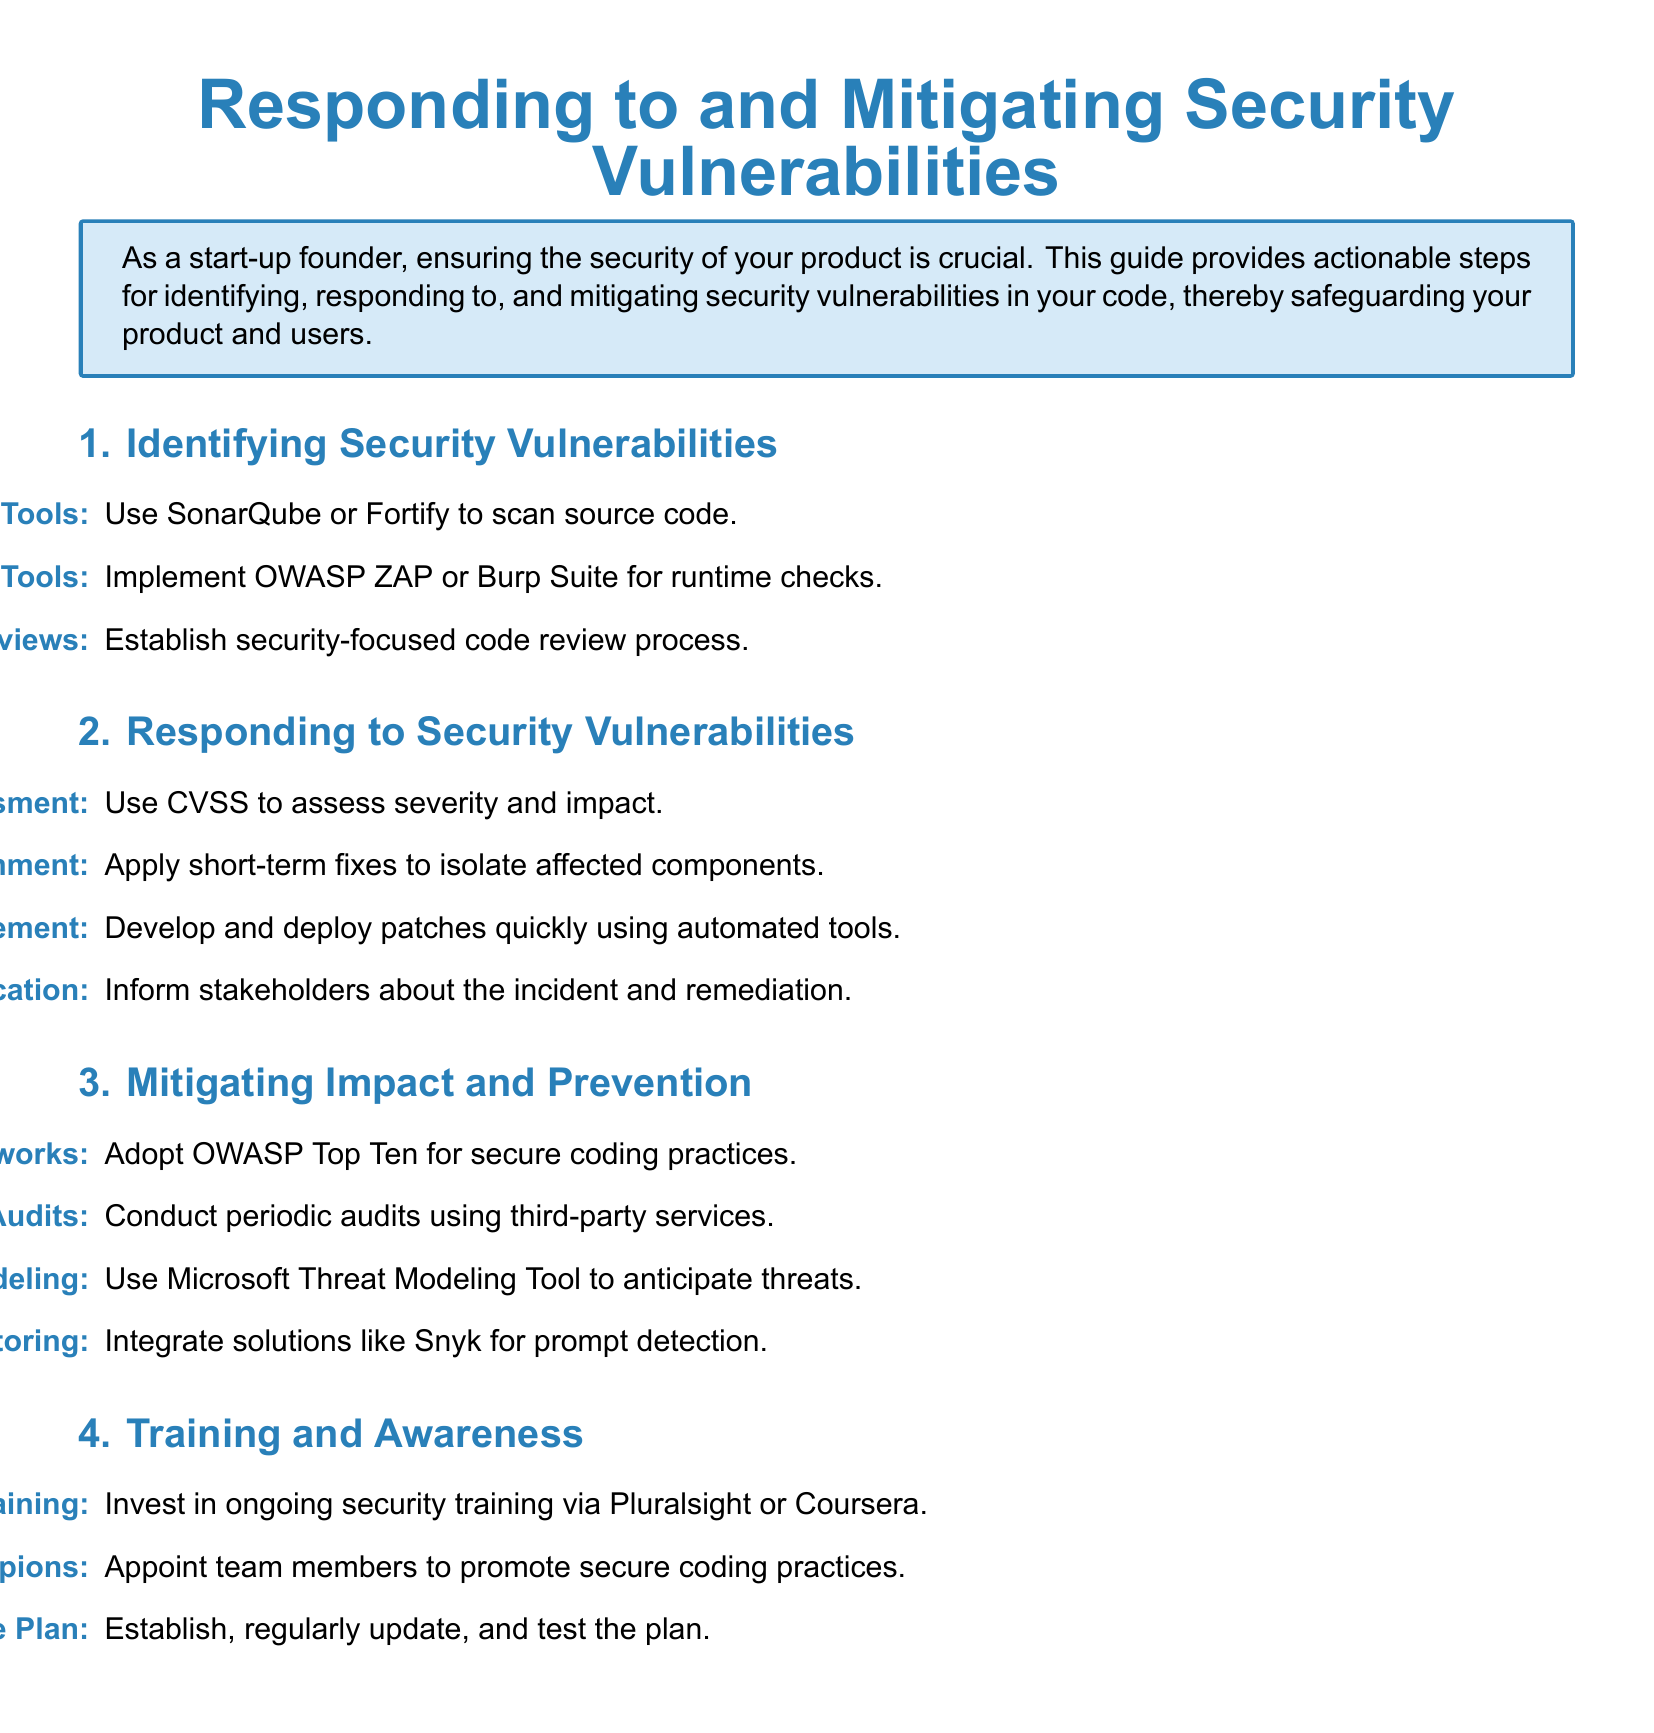What is the purpose of the guide? The guide provides actionable steps for identifying, responding to, and mitigating security vulnerabilities in your code, thereby safeguarding your product and users.
Answer: Safeguarding your product and users What are the names of two static analysis tools mentioned? The document lists SonarQube and Fortify as tools for static analysis.
Answer: SonarQube, Fortify What framework is suggested for secure coding practices? The guide recommends adopting the OWASP Top Ten for secure coding practices.
Answer: OWASP Top Ten How many sections are there in the guide? The document comprises four main sections focused on different aspects of security vulnerabilities.
Answer: Four Which tool is mentioned for conducting periodic audits? The document suggests using third-party services for regular security audits.
Answer: Third-party services What should you do immediately after a vulnerability is detected? The guide indicates that immediate containment involves applying short-term fixes to isolate affected components.
Answer: Apply short-term fixes Which platform is recommended for ongoing security training? The guide mentions Pluralsight or Coursera for developer training.
Answer: Pluralsight or Coursera What is the role of Security Champions? The guide states that team members are appointed to promote secure coding practices.
Answer: Promote secure coding practices 